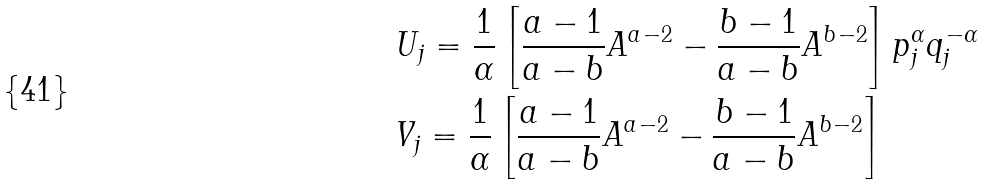<formula> <loc_0><loc_0><loc_500><loc_500>& U _ { j } = \frac { 1 } { \alpha } \left [ \frac { a - 1 } { a - b } A ^ { a - 2 } - \frac { b - 1 } { a - b } A ^ { b - 2 } \right ] p ^ { \alpha } _ { j } q ^ { - \alpha } _ { j } \\ & V _ { j } = \frac { 1 } { \alpha } \left [ \frac { a - 1 } { a - b } A ^ { a - 2 } - \frac { b - 1 } { a - b } A ^ { b - 2 } \right ]</formula> 